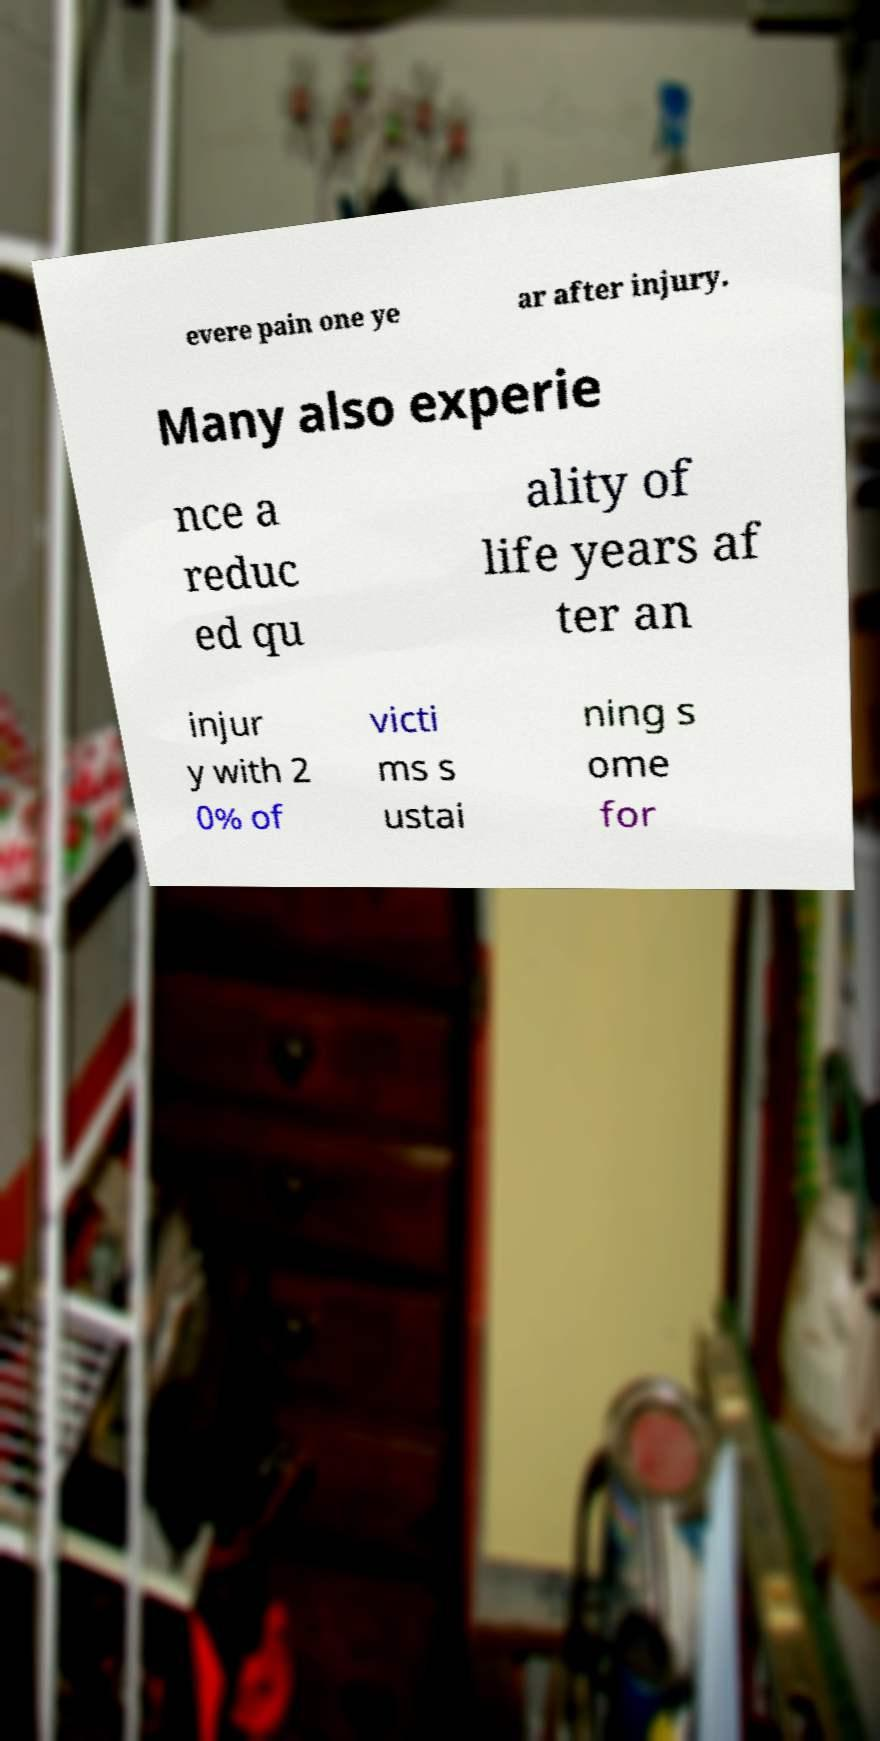Can you accurately transcribe the text from the provided image for me? evere pain one ye ar after injury. Many also experie nce a reduc ed qu ality of life years af ter an injur y with 2 0% of victi ms s ustai ning s ome for 